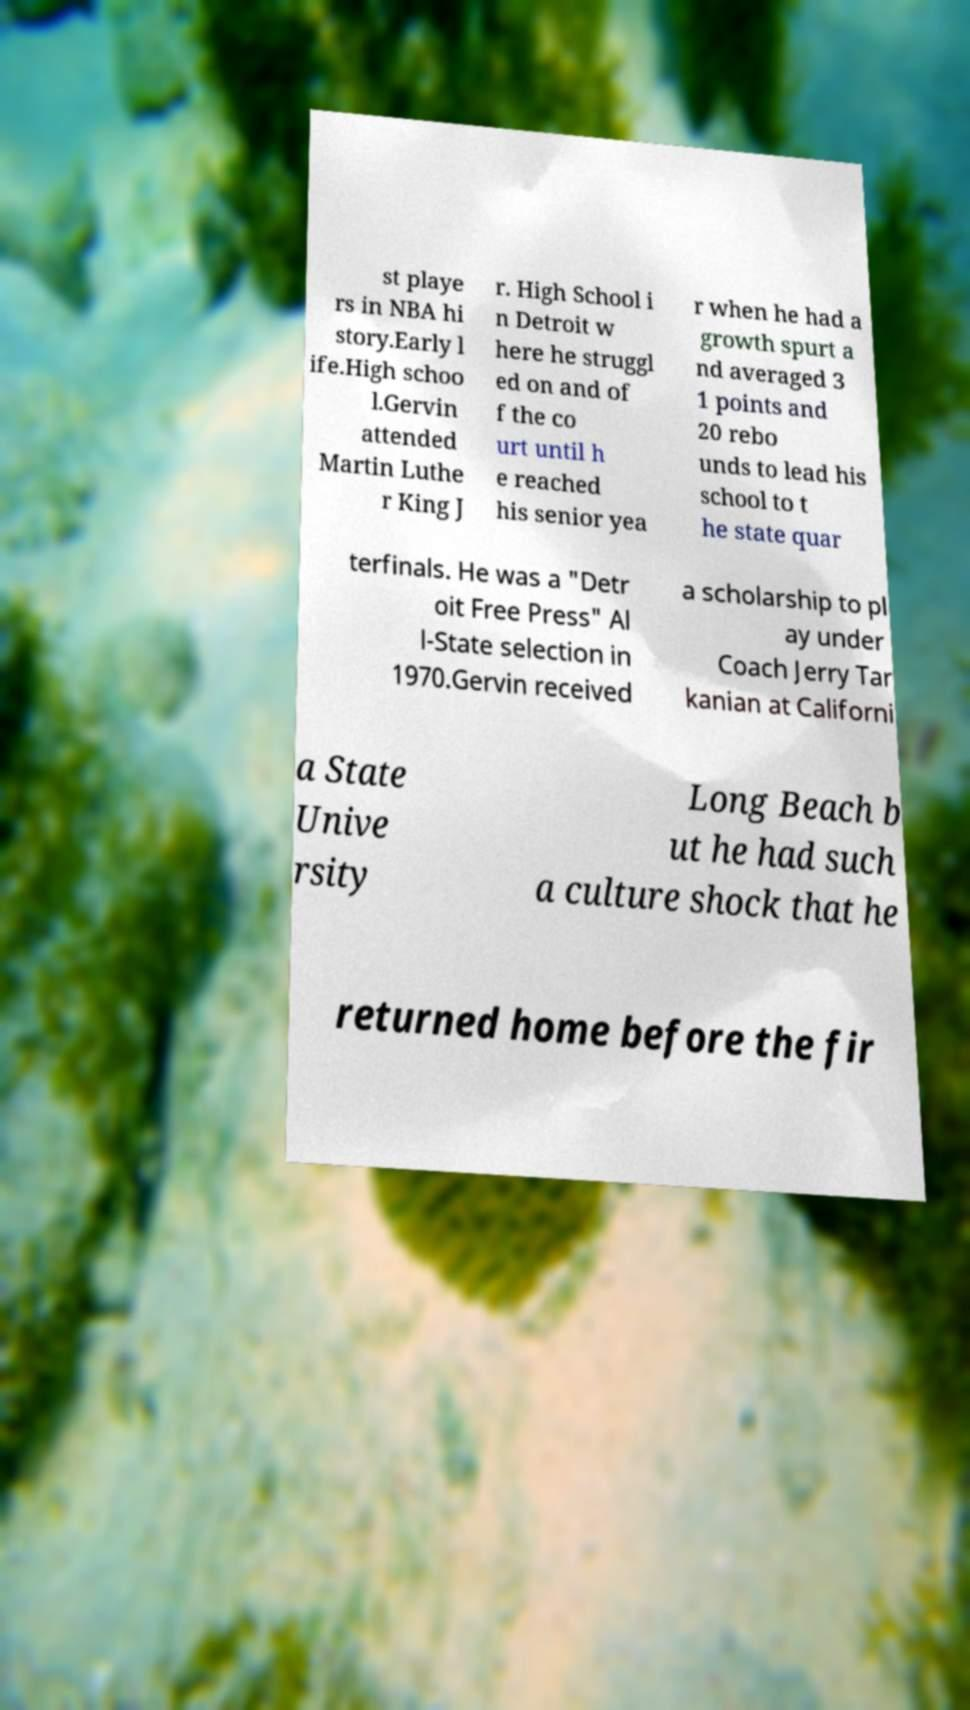Please read and relay the text visible in this image. What does it say? st playe rs in NBA hi story.Early l ife.High schoo l.Gervin attended Martin Luthe r King J r. High School i n Detroit w here he struggl ed on and of f the co urt until h e reached his senior yea r when he had a growth spurt a nd averaged 3 1 points and 20 rebo unds to lead his school to t he state quar terfinals. He was a "Detr oit Free Press" Al l-State selection in 1970.Gervin received a scholarship to pl ay under Coach Jerry Tar kanian at Californi a State Unive rsity Long Beach b ut he had such a culture shock that he returned home before the fir 